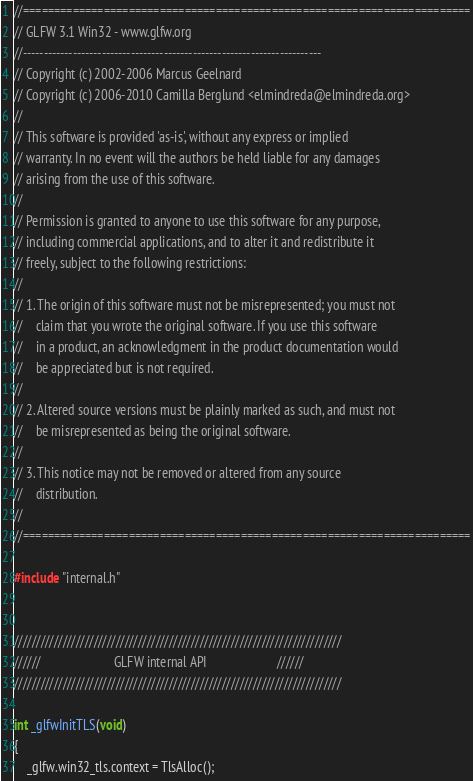Convert code to text. <code><loc_0><loc_0><loc_500><loc_500><_C_>//========================================================================
// GLFW 3.1 Win32 - www.glfw.org
//------------------------------------------------------------------------
// Copyright (c) 2002-2006 Marcus Geelnard
// Copyright (c) 2006-2010 Camilla Berglund <elmindreda@elmindreda.org>
//
// This software is provided 'as-is', without any express or implied
// warranty. In no event will the authors be held liable for any damages
// arising from the use of this software.
//
// Permission is granted to anyone to use this software for any purpose,
// including commercial applications, and to alter it and redistribute it
// freely, subject to the following restrictions:
//
// 1. The origin of this software must not be misrepresented; you must not
//    claim that you wrote the original software. If you use this software
//    in a product, an acknowledgment in the product documentation would
//    be appreciated but is not required.
//
// 2. Altered source versions must be plainly marked as such, and must not
//    be misrepresented as being the original software.
//
// 3. This notice may not be removed or altered from any source
//    distribution.
//
//========================================================================

#include "internal.h"


//////////////////////////////////////////////////////////////////////////
//////                       GLFW internal API                      //////
//////////////////////////////////////////////////////////////////////////

int _glfwInitTLS(void)
{
    _glfw.win32_tls.context = TlsAlloc();</code> 